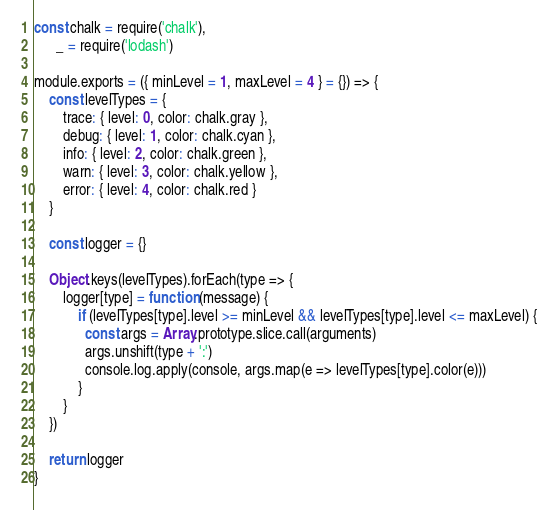<code> <loc_0><loc_0><loc_500><loc_500><_JavaScript_>
const chalk = require('chalk'),
      _ = require('lodash')

module.exports = ({ minLevel = 1, maxLevel = 4 } = {}) => {
	const levelTypes = {
		trace: { level: 0, color: chalk.gray },
		debug: { level: 1, color: chalk.cyan },
		info: { level: 2, color: chalk.green },
		warn: { level: 3, color: chalk.yellow },
		error: { level: 4, color: chalk.red }
	}

	const logger = {}

	Object.keys(levelTypes).forEach(type => {
		logger[type] = function (message) {
			if (levelTypes[type].level >= minLevel && levelTypes[type].level <= maxLevel) {
			  const args = Array.prototype.slice.call(arguments)
			  args.unshift(type + ':')
			  console.log.apply(console, args.map(e => levelTypes[type].color(e)))
			}
		}
	})

	return logger
}</code> 